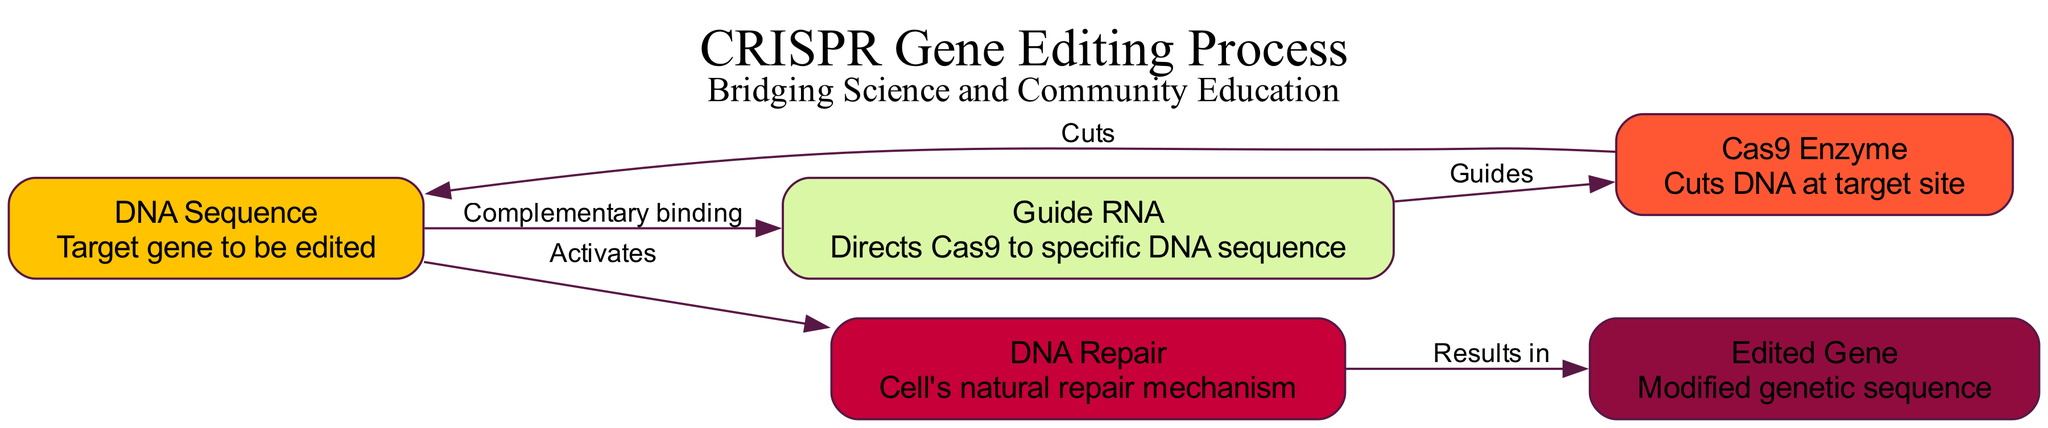What is the target gene to be edited? The first node in the diagram represents the DNA Sequence, labeled as "Target gene to be edited." This is a direct description provided in the node.
Answer: DNA Sequence What is the role of the Guide RNA? The second node defines the function of the Guide RNA, which is to direct the Cas9 enzyme to the specific DNA sequence indicated in the first node. This explanation is derived from the description in the node.
Answer: Directs Cas9 to specific DNA sequence How many nodes are present in the diagram? There are five nodes listed under the "nodes" section in the data. Counting each entry confirms that there are a total of five unique nodes represented in the diagram.
Answer: 5 Which node activates the DNA Repair mechanism? The flow from the DNA Sequence (first node) to the DNA Repair (fourth node) is indicated by the edge labeled "Activates." Therefore, the DNA Sequence activates the DNA Repair mechanism as specified in the edge label.
Answer: DNA Sequence What is the final output produced after DNA Repair? The diagram shows an edge leading from the DNA Repair node to the Edited Gene node, labeled "Results in." This indicates that the outcome of the DNA Repair process is the Edited Gene. Therefore, the final output after DNA Repair is the Edited Gene.
Answer: Edited Gene What does the Cas9 Enzyme do in the editing process? The Cas9 Enzyme is described in its node as cutting DNA at the target site indicated by the first node. This means its primary function within the process is to introduce breaks in the DNA sequence where editing is targeted.
Answer: Cuts DNA at target site What relationship exists between the Guide RNA and the Cas9 Enzyme? The edge connecting the Guide RNA (second node) to the Cas9 Enzyme (third node) is labeled "Guides." This indicates that the Guide RNA provides the necessary direction for the Cas9 enzyme to reach its target DNA sequence.
Answer: Guides What activates the cell's natural repair mechanism? According to the diagram, the activation process is indicated by the edge connecting the DNA Sequence to the DNA Repair node labeled "Activates." Hence, the DNA Sequence activates the cell's natural repair mechanism.
Answer: DNA Sequence 